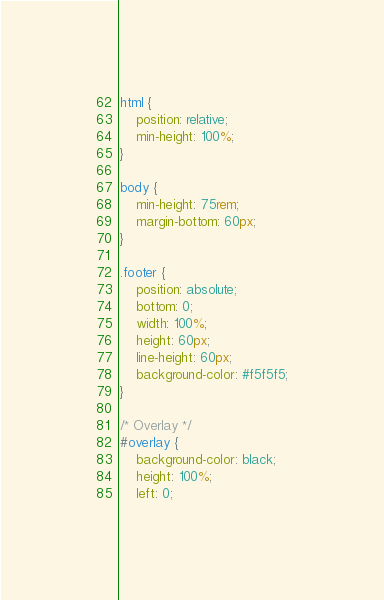<code> <loc_0><loc_0><loc_500><loc_500><_CSS_>html {
    position: relative;
    min-height: 100%;
}

body {
    min-height: 75rem;
    margin-bottom: 60px;
}

.footer {
    position: absolute;
    bottom: 0;
    width: 100%;
    height: 60px;
    line-height: 60px;
    background-color: #f5f5f5;
}

/* Overlay */
#overlay {
    background-color: black;
    height: 100%;
    left: 0;</code> 